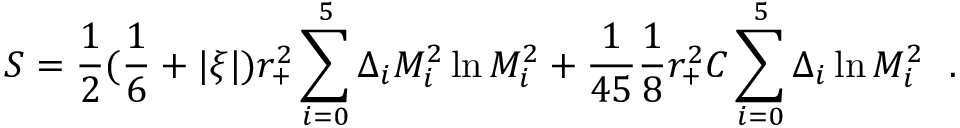<formula> <loc_0><loc_0><loc_500><loc_500>S = { \frac { 1 } { 2 } } ( { \frac { 1 } { 6 } } + | \xi | ) r _ { + } ^ { 2 } \sum _ { i = 0 } ^ { 5 } \Delta _ { i } M _ { i } ^ { 2 } \ln M _ { i } ^ { 2 } + { \frac { 1 } { 4 5 } } { \frac { 1 } { 8 } } r _ { + } ^ { 2 } C \sum _ { i = 0 } ^ { 5 } \Delta _ { i } \ln M _ { i } ^ { 2 } .</formula> 